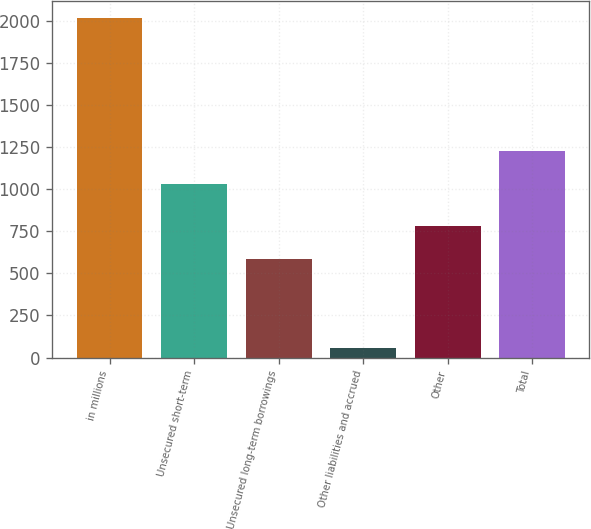Convert chart to OTSL. <chart><loc_0><loc_0><loc_500><loc_500><bar_chart><fcel>in millions<fcel>Unsecured short-term<fcel>Unsecured long-term borrowings<fcel>Other liabilities and accrued<fcel>Other<fcel>Total<nl><fcel>2016<fcel>1028<fcel>584<fcel>55<fcel>780.1<fcel>1224.1<nl></chart> 